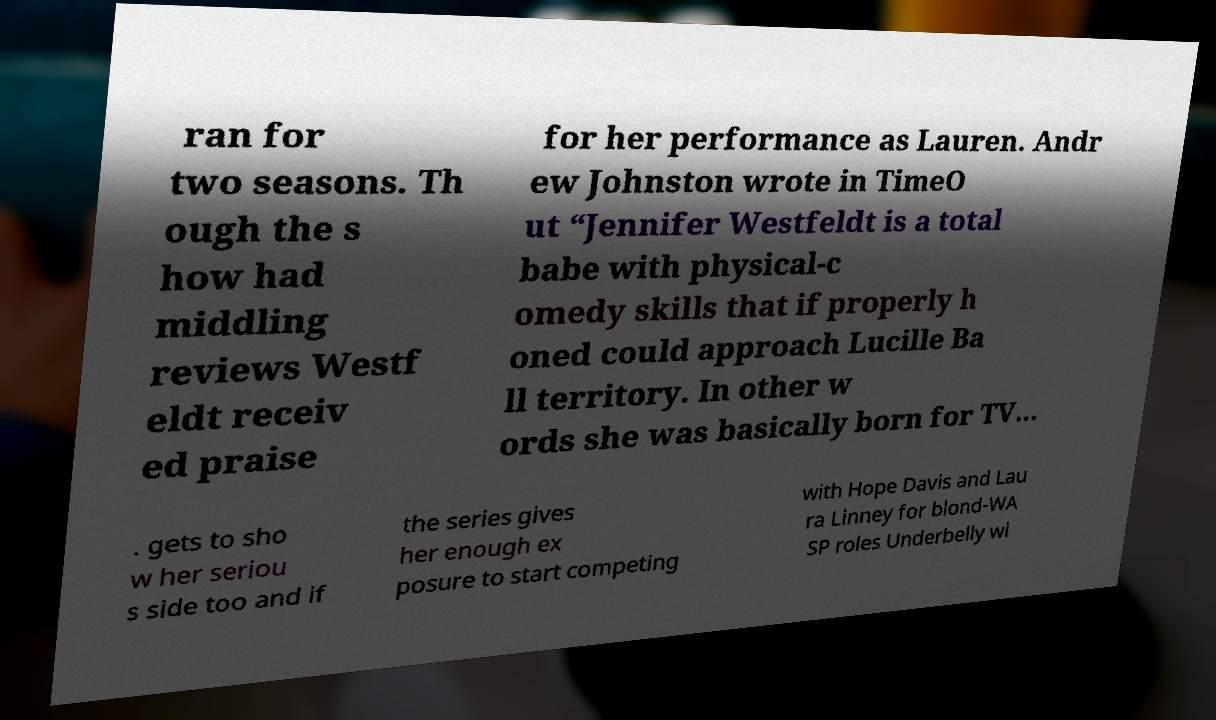Please read and relay the text visible in this image. What does it say? ran for two seasons. Th ough the s how had middling reviews Westf eldt receiv ed praise for her performance as Lauren. Andr ew Johnston wrote in TimeO ut “Jennifer Westfeldt is a total babe with physical-c omedy skills that if properly h oned could approach Lucille Ba ll territory. In other w ords she was basically born for TV… . gets to sho w her seriou s side too and if the series gives her enough ex posure to start competing with Hope Davis and Lau ra Linney for blond-WA SP roles Underbelly wi 